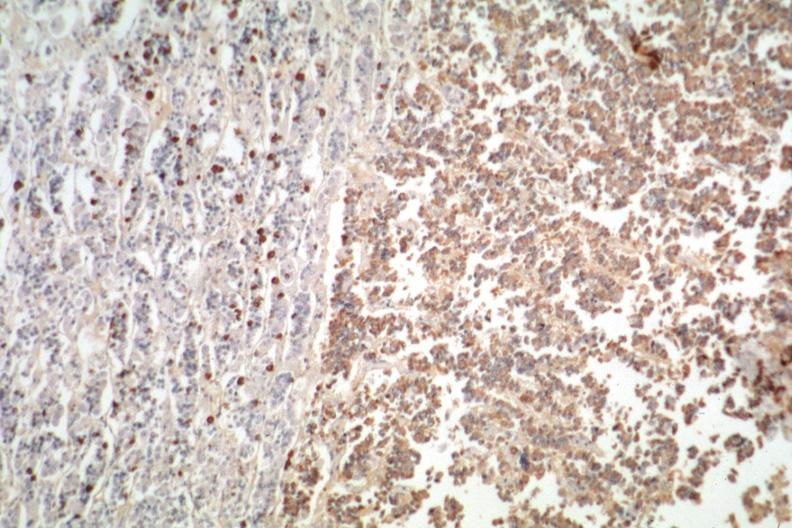s eosinophilic adenoma present?
Answer the question using a single word or phrase. Yes 